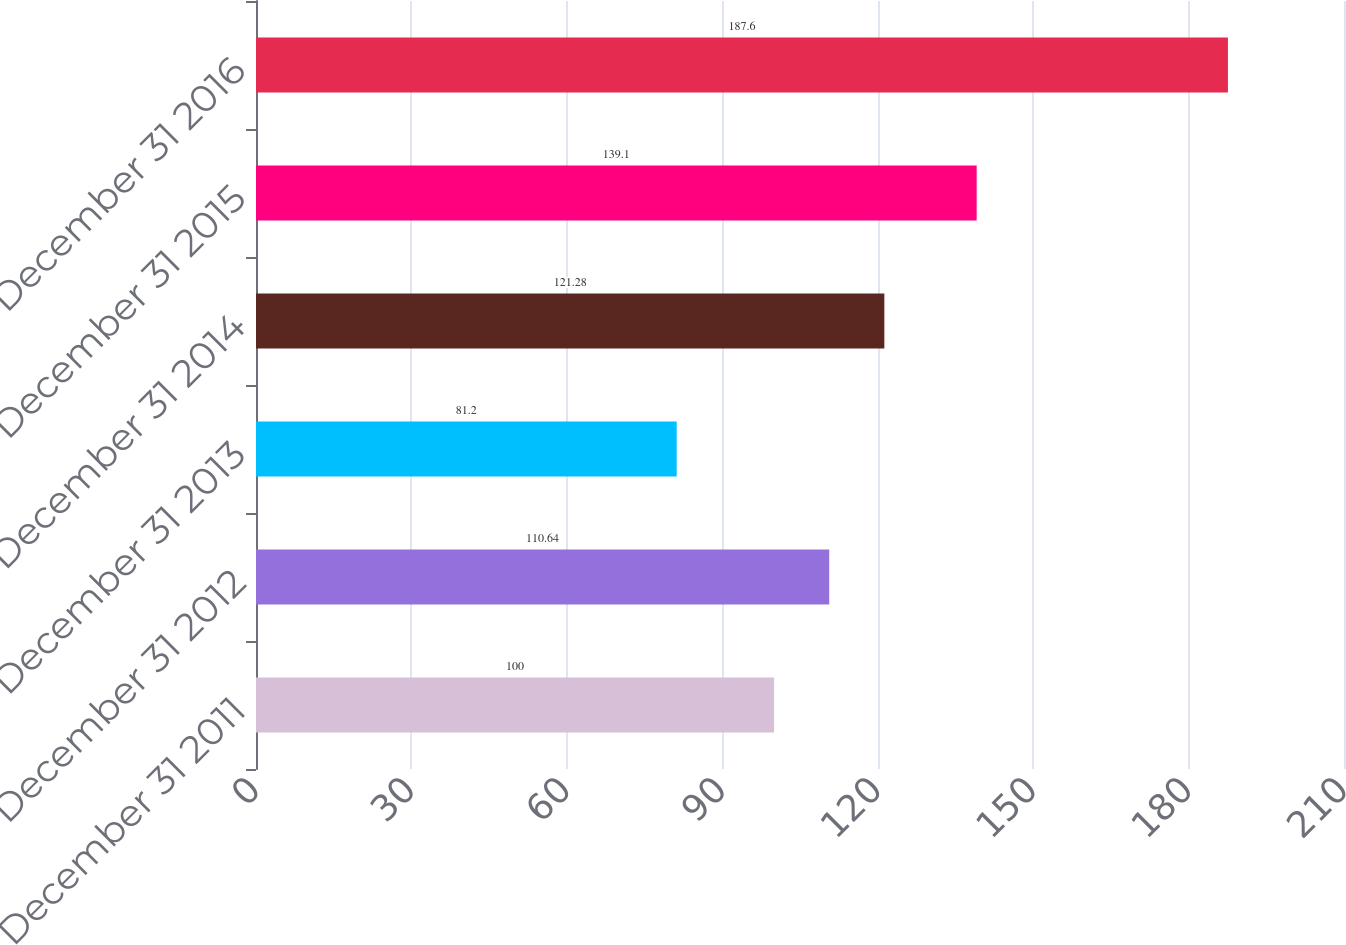<chart> <loc_0><loc_0><loc_500><loc_500><bar_chart><fcel>December 31 2011<fcel>December 31 2012<fcel>December 31 2013<fcel>December 31 2014<fcel>December 31 2015<fcel>December 31 2016<nl><fcel>100<fcel>110.64<fcel>81.2<fcel>121.28<fcel>139.1<fcel>187.6<nl></chart> 